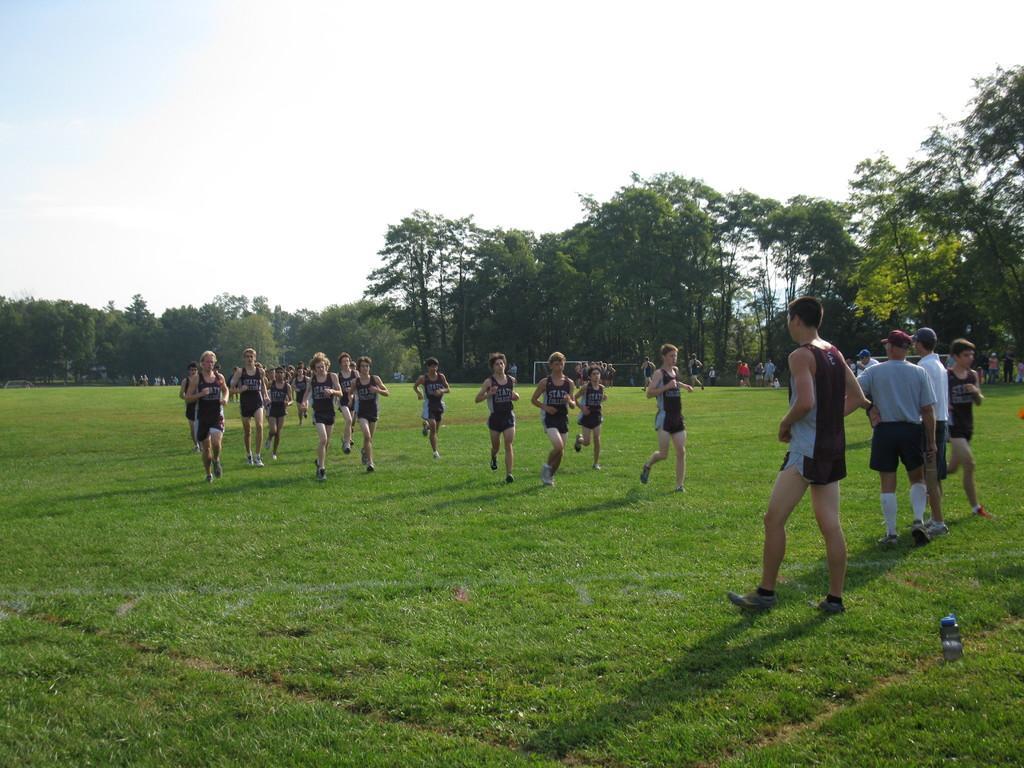How would you summarize this image in a sentence or two? In this image we can see some people running on the ground. On the right side of the image we can see some people standing on the grass field. In the background, we can see goal posts and group of trees. At the top of the image we can see the sky. 